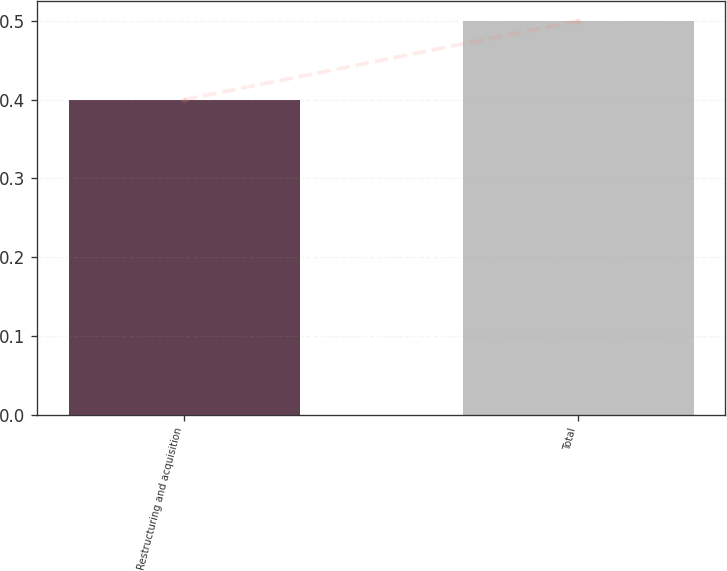Convert chart. <chart><loc_0><loc_0><loc_500><loc_500><bar_chart><fcel>Restructuring and acquisition<fcel>Total<nl><fcel>0.4<fcel>0.5<nl></chart> 